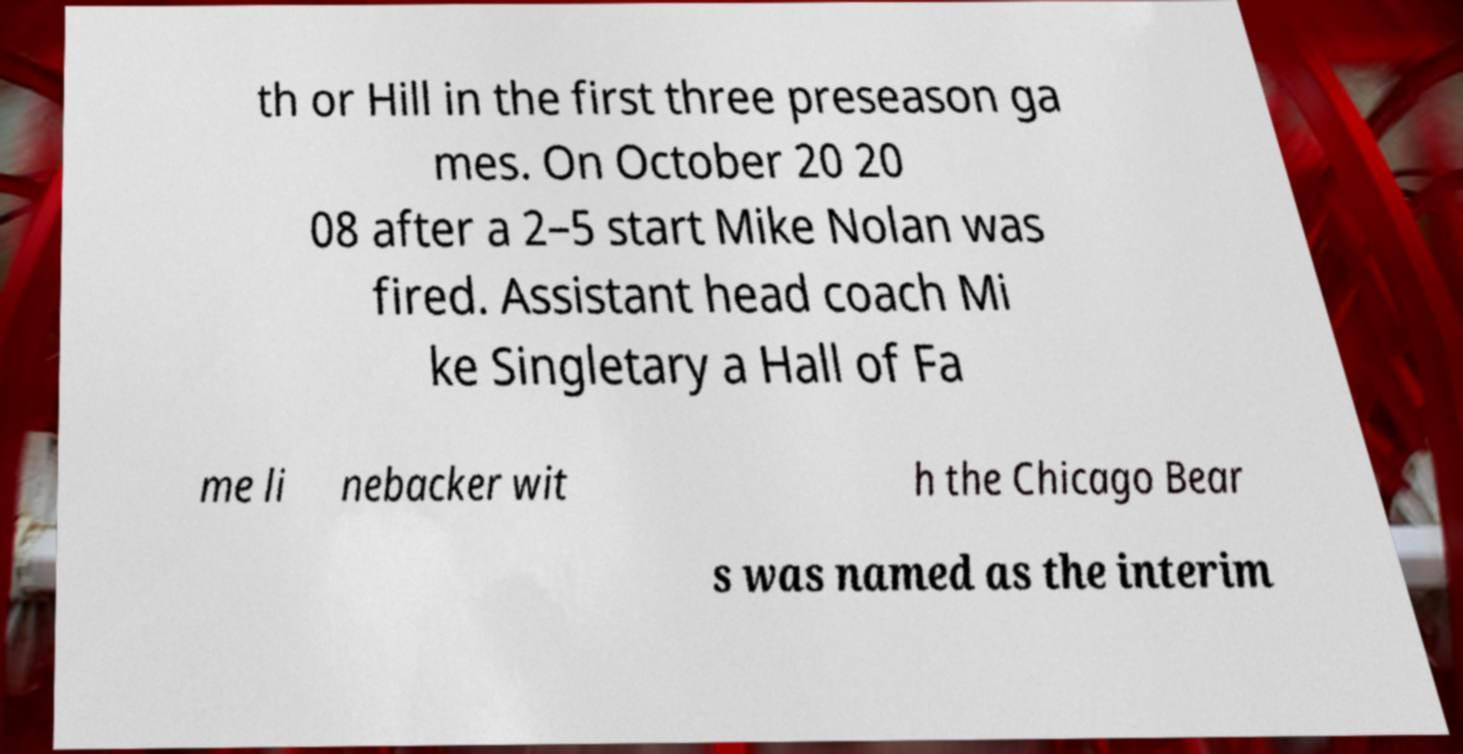For documentation purposes, I need the text within this image transcribed. Could you provide that? th or Hill in the first three preseason ga mes. On October 20 20 08 after a 2–5 start Mike Nolan was fired. Assistant head coach Mi ke Singletary a Hall of Fa me li nebacker wit h the Chicago Bear s was named as the interim 